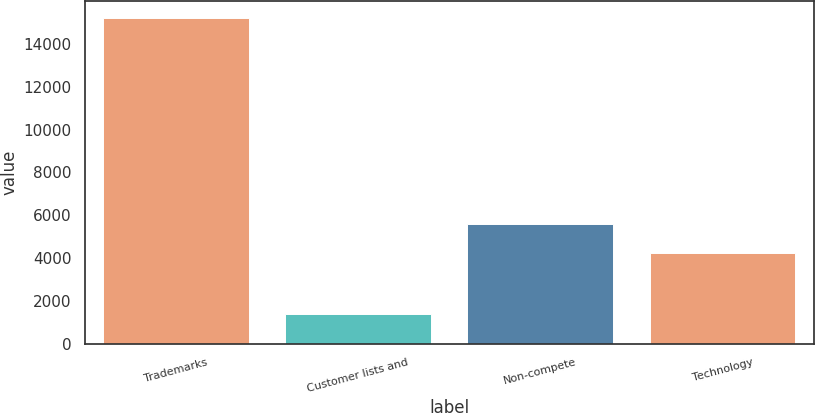Convert chart. <chart><loc_0><loc_0><loc_500><loc_500><bar_chart><fcel>Trademarks<fcel>Customer lists and<fcel>Non-compete<fcel>Technology<nl><fcel>15220<fcel>1391<fcel>5615.9<fcel>4233<nl></chart> 